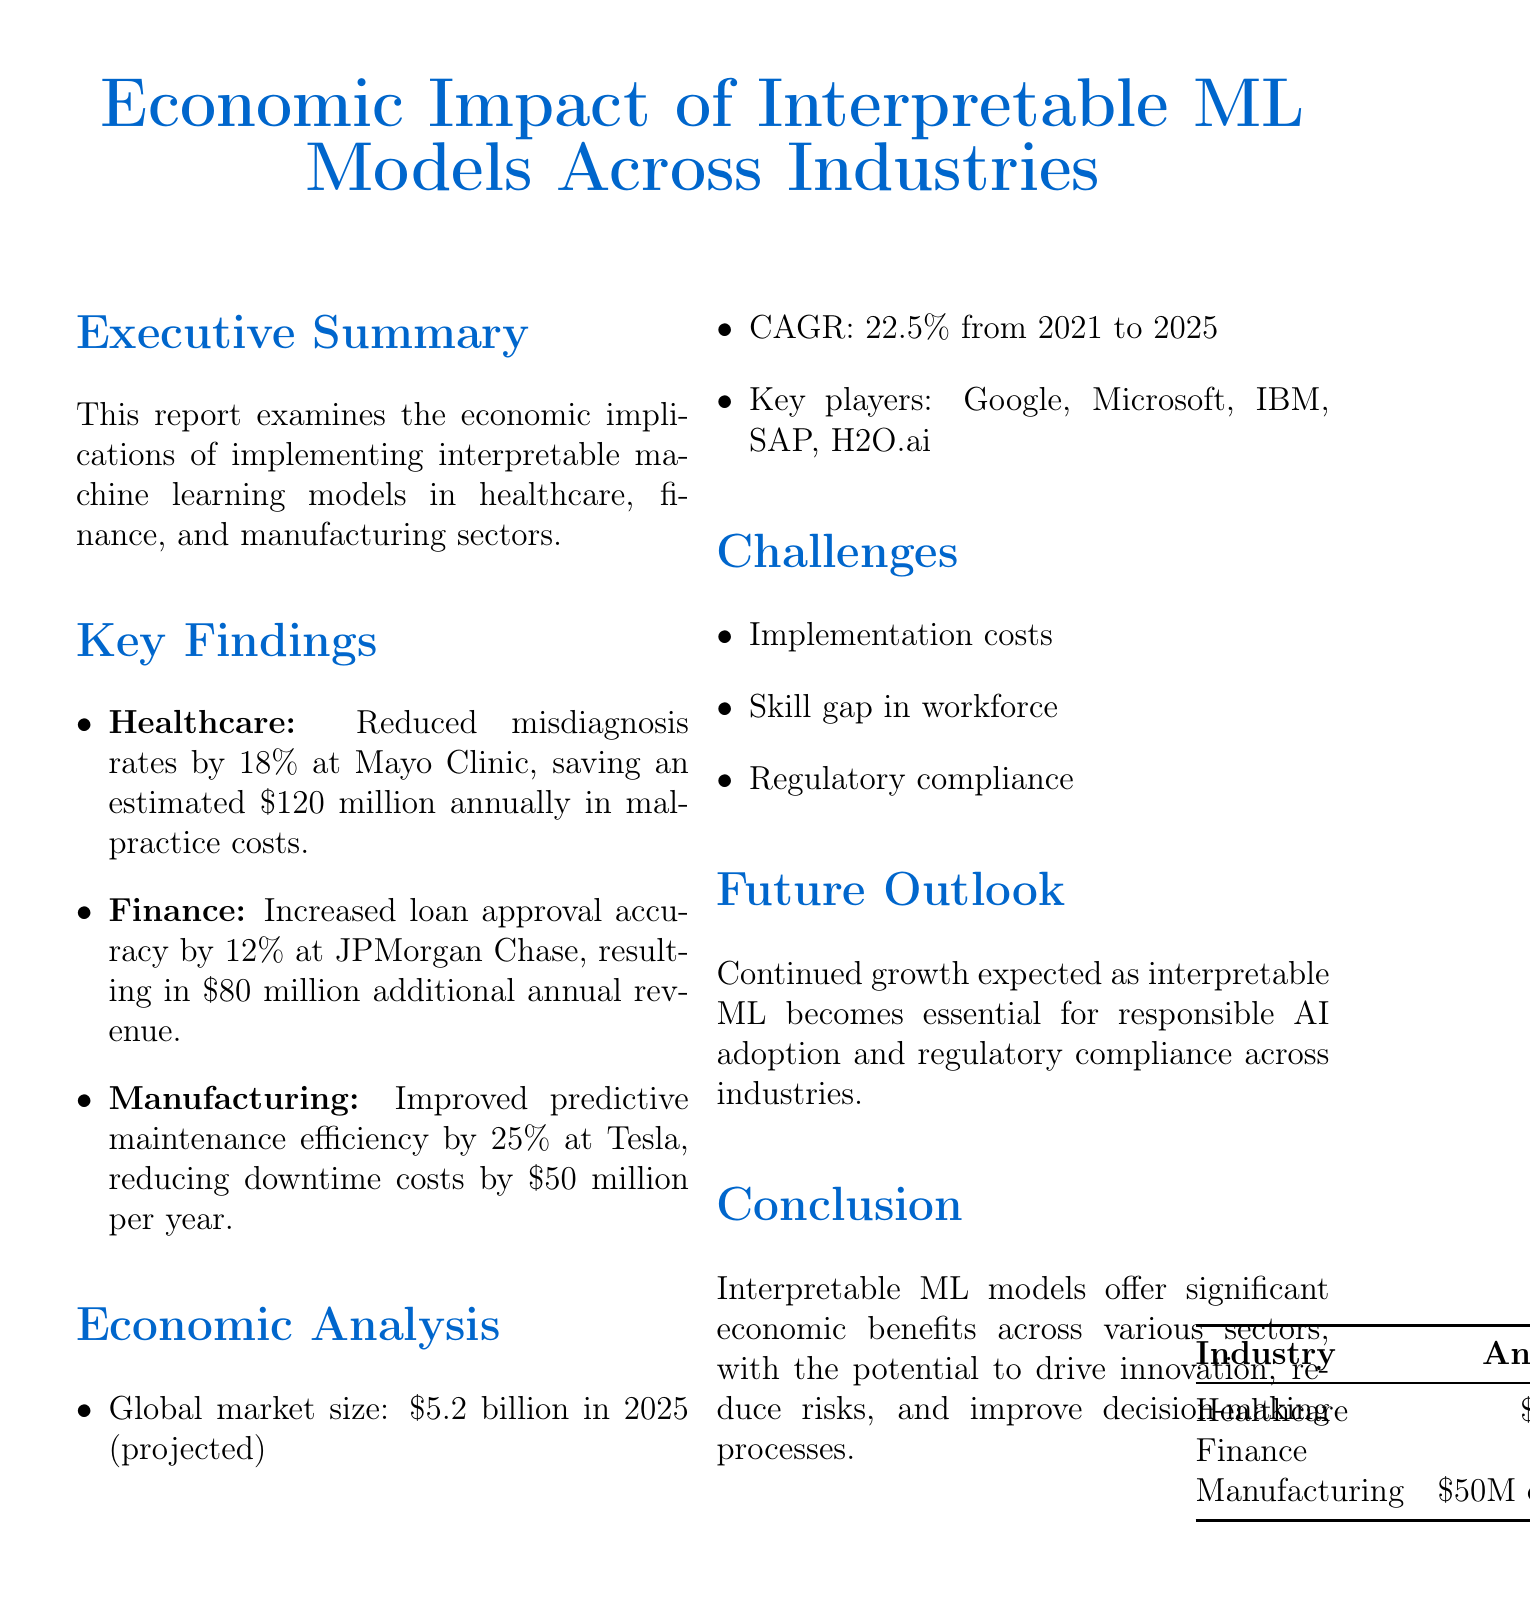What is the projected global market size in 2025? The global market size is mentioned in the economic analysis section of the report as $5.2 billion in 2025.
Answer: $5.2 billion What percentage of misdiagnosis rate reduction was achieved in healthcare? The report states that there was an 18% reduction in misdiagnosis rates at Mayo Clinic in the healthcare section.
Answer: 18% Which company implemented interpretable AI for cancer diagnosis? In the case study listed under healthcare, IBM Watson Health is mentioned as the company behind the interpretable AI for cancer diagnosis.
Answer: IBM Watson Health What is the total estimated annual savings in malpractice costs at Mayo Clinic? The report provides an estimated saving of $120 million annually in malpractice costs for the healthcare sector.
Answer: $120 million What was the increase in loan approval accuracy at JPMorgan Chase? The finance section indicates that loan approval accuracy increased by 12% at JPMorgan Chase.
Answer: 12% Which key player is listed in the economic analysis section? The economic analysis lists several key players, one of which is Microsoft.
Answer: Microsoft What is the estimated reduction in downtime costs at Tesla? The manufacturing section reports that predictive maintenance efficiency improved and downtime costs were reduced by $50 million per year.
Answer: $50 million What is the CAGR from 2021 to 2025? The economic analysis section includes a CAGR of 22.5% from 2021 to 2025.
Answer: 22.5% What is a significant challenge mentioned in the report? The report lists various challenges, including implementation costs as a significant challenge in adopting interpretable machine learning models.
Answer: Implementation costs 